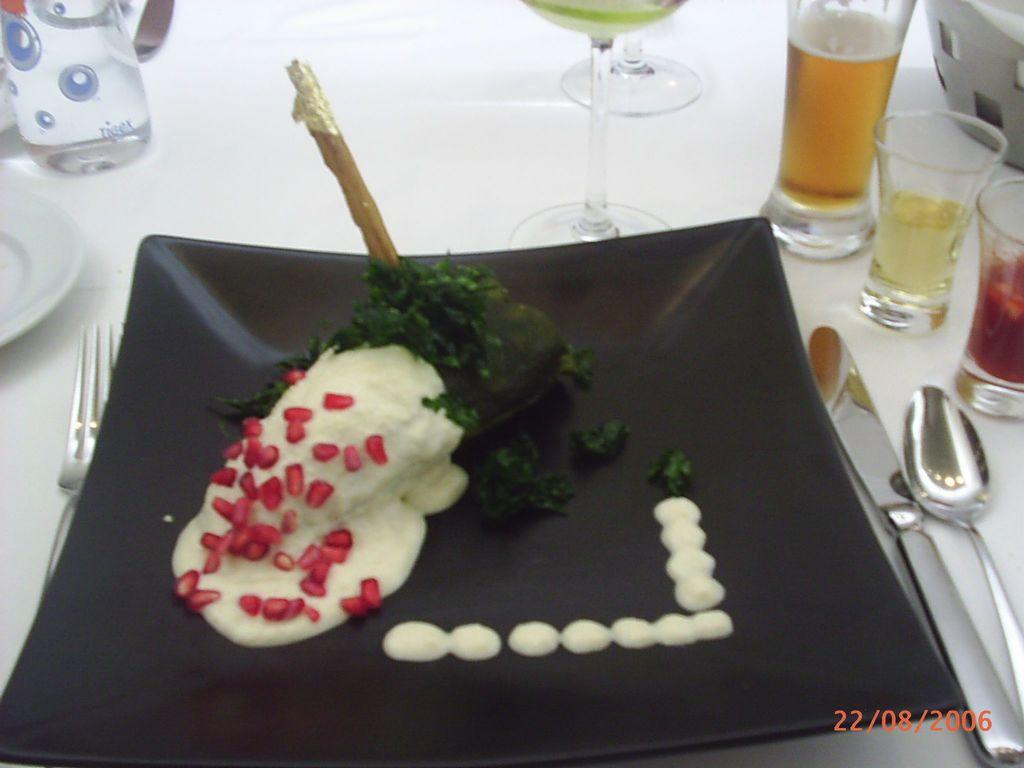What type of items can be seen in the image related to eating? There is food, glasses, a plate, forks, knives, and spoons in the image. How many different types of utensils are visible in the image? There are four different types of utensils visible in the image: forks, knives, spoons, and glasses. What might be used to serve the food in the image? The plate in the image might be used to serve the food. What type of waves can be seen in the image? There are no waves present in the image; it features food, glasses, a plate, and various utensils. 